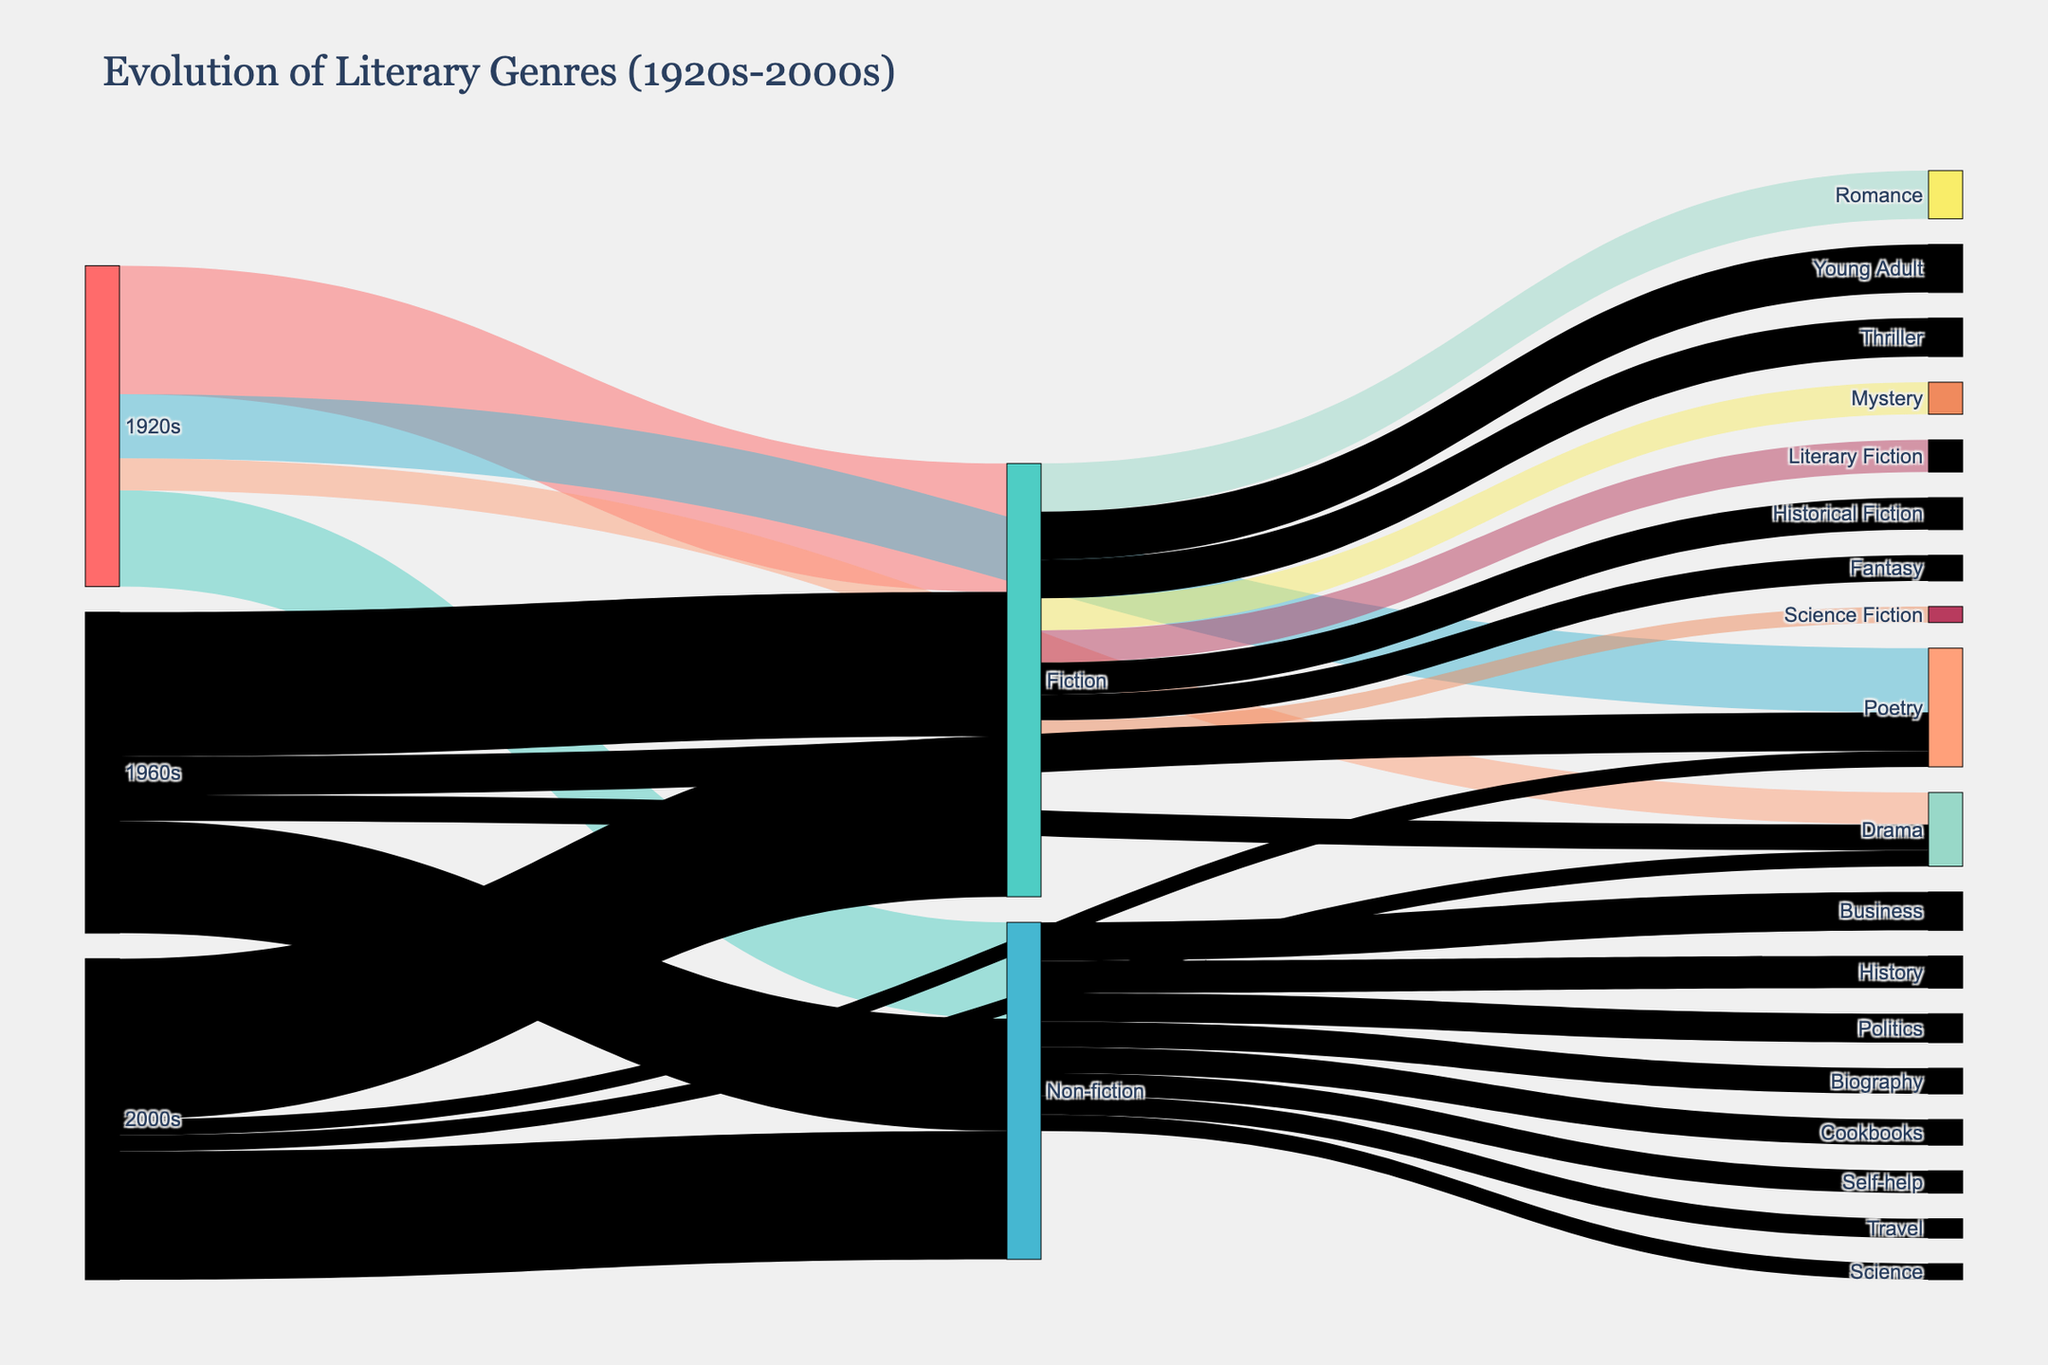what are the largest and smallest genres in the 1920s? To determine the largest and smallest genres in the 1920s, look at the values linked from the 1920s node. The largest value is for Fiction (40) and the smallest value is for Drama (10).
Answer: Fiction is the largest (40), Drama is the smallest (10) Which literary genre from Fiction had the highest value in the 2000s? To find the highest value for a sub-genre under Fiction in the 2000s, look at the targets linked from Fiction in the 2000s. Young Adult has the highest value with 15.
Answer: Young Adult (15) How did the market share of Poetry change from the 1920s to the 2000s? Compare the values of Poetry from the 1920s (20), 1960s (12), and 2000s (5). The value decreased first to 12 in the 1960s, then to 5 in the 2000s.
Answer: Decreased from 20 to 5 Which decade shows the largest increase in Fiction market share? To find out the largest increase, compare the values across the decades: 1920s (40), 1960s (45), and 2000s (50). The largest increase is from the 1920s to 1960s (5) and the 1960s to 2000s (5) are both 5.
Answer: Both from 1920s to 1960s and 1960s to 2000s (5) Which sub-genres of Non-fiction were introduced in the 2000s? Look at the Non-fiction node in the 2000s and identify the sub-genres not present in earlier decades. Business and Cookbooks are new introductions.
Answer: Business and Cookbooks How do the values for Drama change over the decades? Track the Drama node from the 1920s (10), 1960s (8), to the 2000s (5). Drama's value decreases progressively over these decades.
Answer: Decreases from 10 to 5 By how much did the market share of Non-fiction increase from the 1920s to the 2000s? Compare the values of Non-fiction in the 1920s (30) to 1960s (35) to 2000s (40). The total increase is 40 - 30 = 10.
Answer: Increased by 10 What is the total market share of genres derived from Fiction in the 1960s and 2000s? Sum the values of all Fiction sub-genres for both decades. For the 1960s: Thriller (12) + Fantasy (8) = 20. For the 2000s: Young Adult (15) + Historical Fiction (10) = 25.
Answer: 20 in the 1960s, 25 in the 2000s Which period had the most significant genre diversity for Non-fiction? Look at the number of distinct Non-fiction sub-genres per period: 1920s (4 - History, Biography, Self-help, Science), 1960s (2 - Politics, Travel), and 2000s (2 - Business, Cookbooks). The 1920s has the most Non-fiction diversity with 4 sub-genres.
Answer: The 1920s 